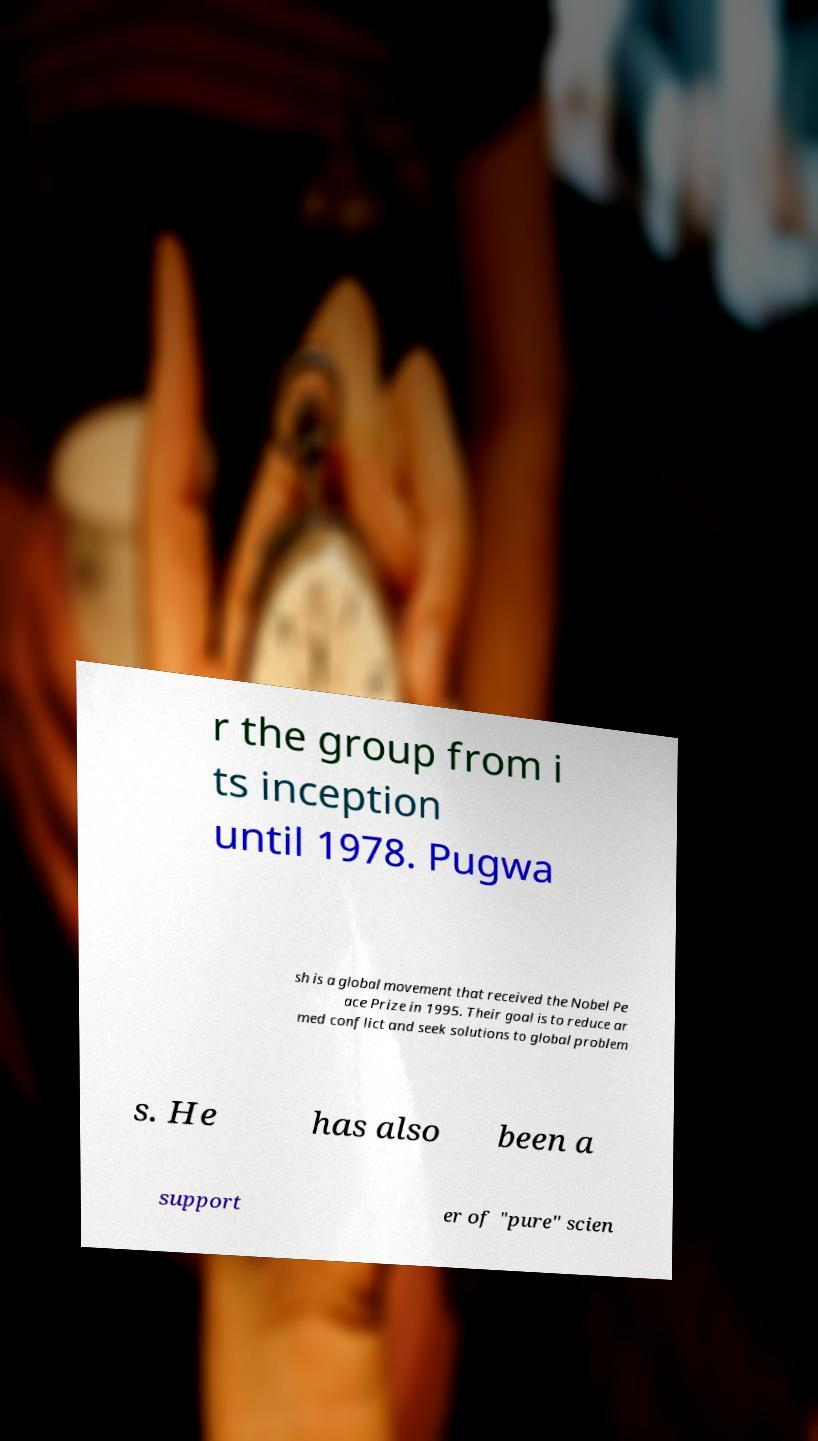I need the written content from this picture converted into text. Can you do that? r the group from i ts inception until 1978. Pugwa sh is a global movement that received the Nobel Pe ace Prize in 1995. Their goal is to reduce ar med conflict and seek solutions to global problem s. He has also been a support er of "pure" scien 